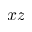Convert formula to latex. <formula><loc_0><loc_0><loc_500><loc_500>x z</formula> 